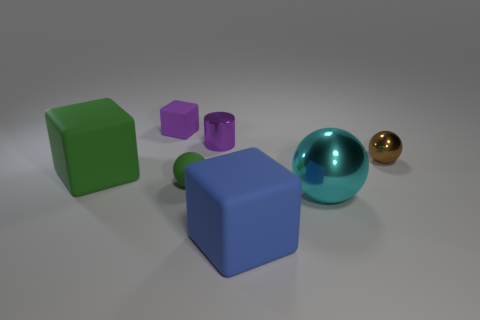How many blocks are in front of the cyan metallic ball and behind the cyan shiny thing?
Offer a very short reply. 0. There is a large block that is in front of the shiny ball that is in front of the tiny brown shiny object; are there any big cyan metal things on the left side of it?
Your response must be concise. No. There is a green thing that is the same size as the blue matte cube; what is its shape?
Give a very brief answer. Cube. Are there any spheres that have the same color as the large metal thing?
Offer a terse response. No. Is the shape of the tiny brown object the same as the big blue matte object?
Offer a terse response. No. How many small things are either blue metallic objects or cyan metallic balls?
Provide a succinct answer. 0. What is the color of the tiny cylinder that is the same material as the big ball?
Your answer should be very brief. Purple. How many cyan balls have the same material as the cyan object?
Offer a very short reply. 0. There is a shiny object to the left of the blue cube; is it the same size as the thing that is on the right side of the large cyan metal thing?
Offer a very short reply. Yes. There is a big block in front of the shiny ball that is in front of the small brown metallic ball; what is its material?
Offer a terse response. Rubber. 